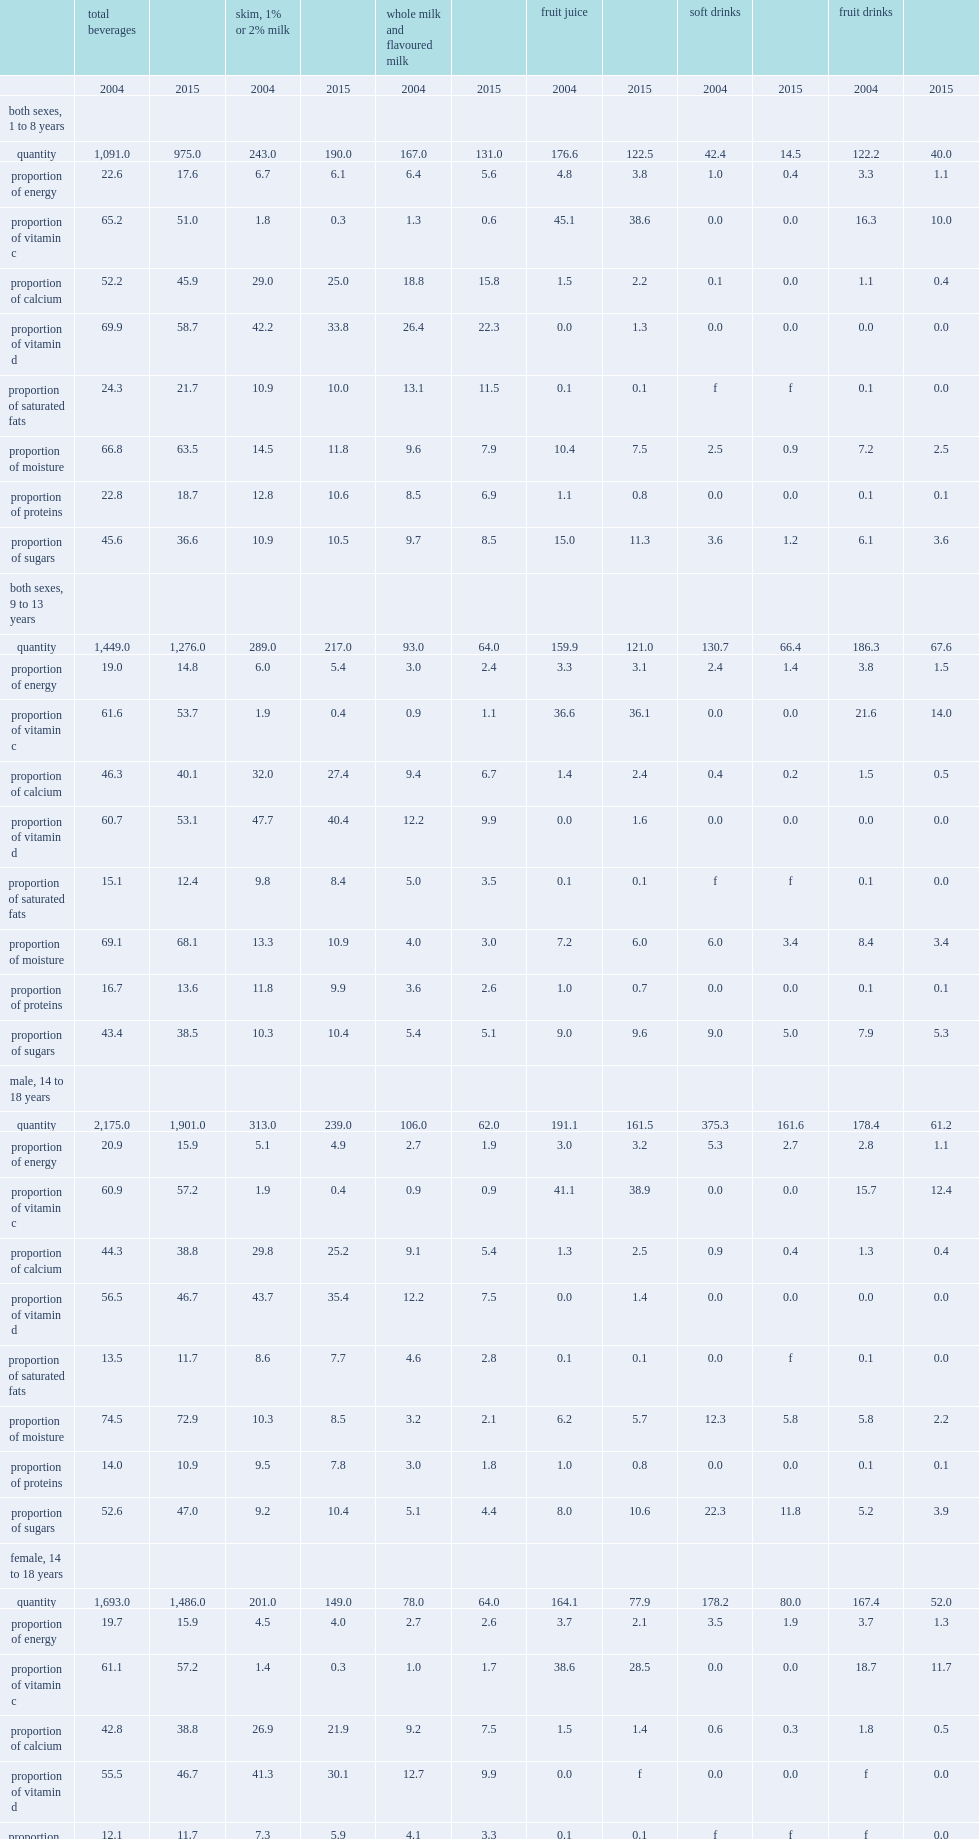What is the percentage points that the contribution of total beverage to daily energy intake lower in 2015 than in 2004? 4.5. 